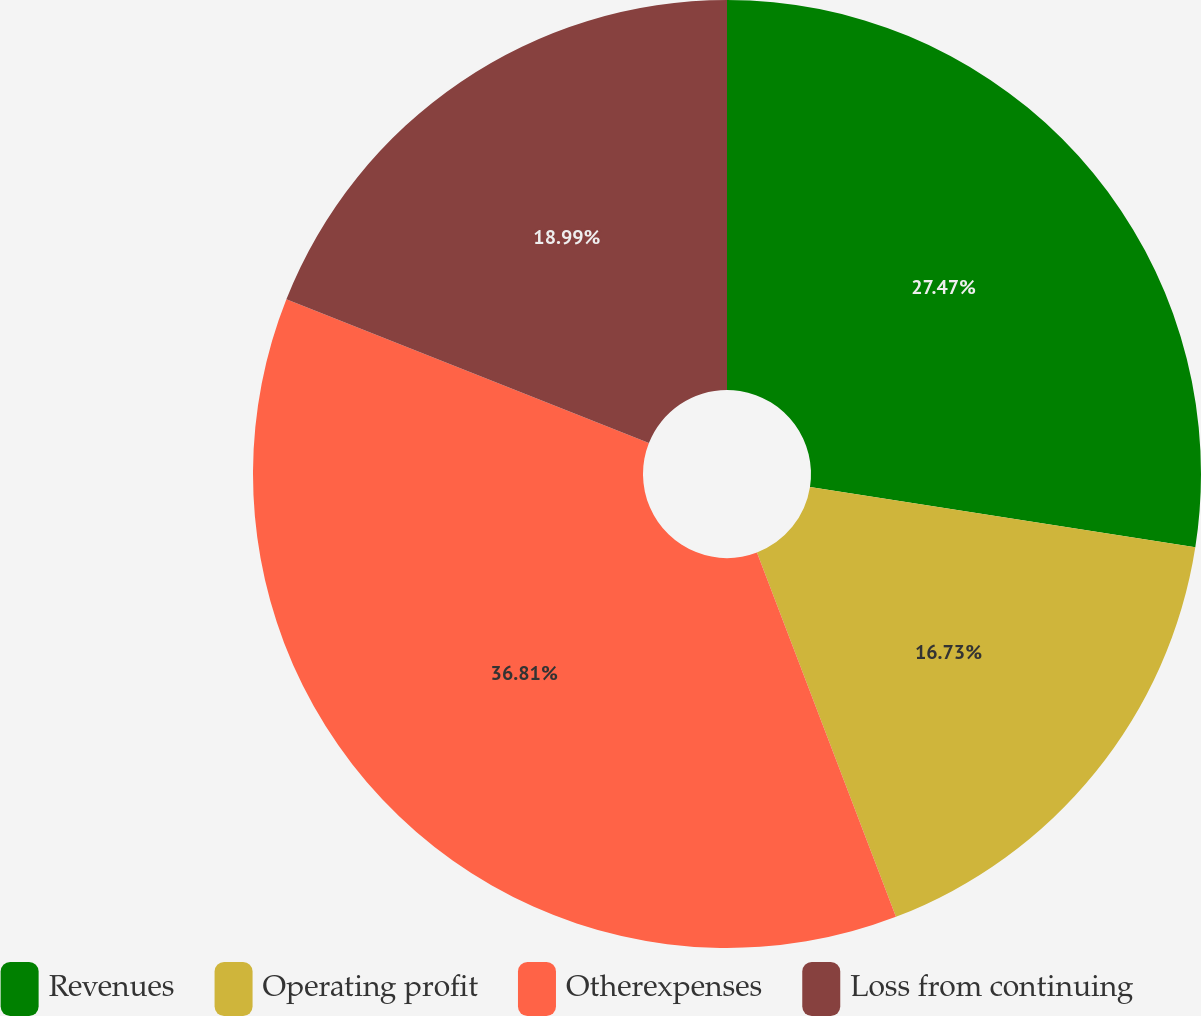Convert chart. <chart><loc_0><loc_0><loc_500><loc_500><pie_chart><fcel>Revenues<fcel>Operating profit<fcel>Otherexpenses<fcel>Loss from continuing<nl><fcel>27.47%<fcel>16.73%<fcel>36.81%<fcel>18.99%<nl></chart> 